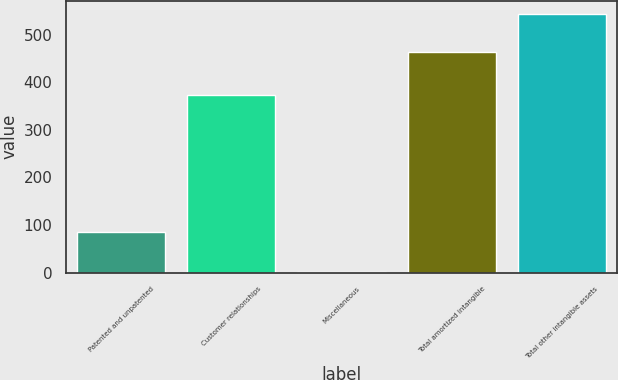Convert chart. <chart><loc_0><loc_0><loc_500><loc_500><bar_chart><fcel>Patented and unpatented<fcel>Customer relationships<fcel>Miscellaneous<fcel>Total amortized intangible<fcel>Total other intangible assets<nl><fcel>86.3<fcel>374.2<fcel>2.6<fcel>463.1<fcel>543.8<nl></chart> 